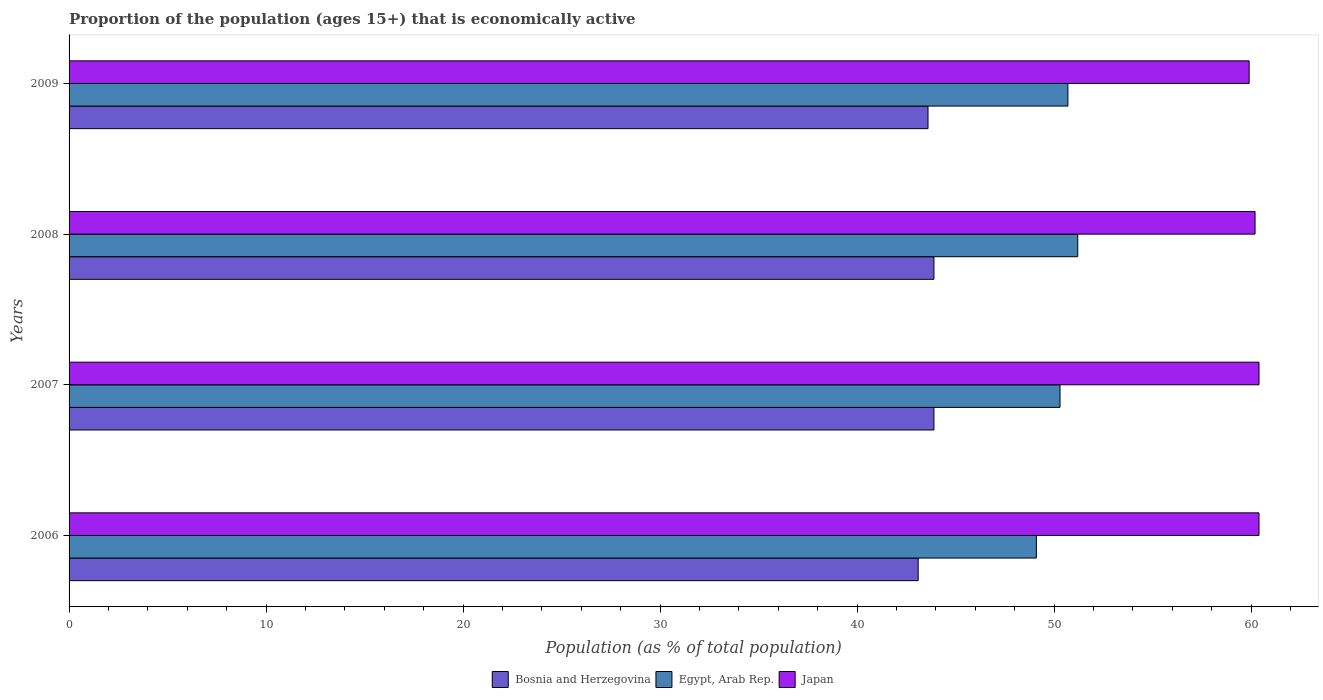Are the number of bars per tick equal to the number of legend labels?
Give a very brief answer. Yes. How many bars are there on the 3rd tick from the top?
Give a very brief answer. 3. What is the proportion of the population that is economically active in Bosnia and Herzegovina in 2008?
Your response must be concise. 43.9. Across all years, what is the maximum proportion of the population that is economically active in Japan?
Offer a very short reply. 60.4. Across all years, what is the minimum proportion of the population that is economically active in Japan?
Offer a terse response. 59.9. In which year was the proportion of the population that is economically active in Bosnia and Herzegovina maximum?
Provide a succinct answer. 2007. In which year was the proportion of the population that is economically active in Bosnia and Herzegovina minimum?
Provide a succinct answer. 2006. What is the total proportion of the population that is economically active in Bosnia and Herzegovina in the graph?
Make the answer very short. 174.5. What is the difference between the proportion of the population that is economically active in Japan in 2006 and that in 2009?
Make the answer very short. 0.5. What is the difference between the proportion of the population that is economically active in Japan in 2006 and the proportion of the population that is economically active in Egypt, Arab Rep. in 2009?
Offer a terse response. 9.7. What is the average proportion of the population that is economically active in Bosnia and Herzegovina per year?
Provide a succinct answer. 43.62. In the year 2006, what is the difference between the proportion of the population that is economically active in Japan and proportion of the population that is economically active in Bosnia and Herzegovina?
Provide a succinct answer. 17.3. In how many years, is the proportion of the population that is economically active in Egypt, Arab Rep. greater than 42 %?
Offer a terse response. 4. What is the ratio of the proportion of the population that is economically active in Egypt, Arab Rep. in 2006 to that in 2007?
Offer a very short reply. 0.98. Is the difference between the proportion of the population that is economically active in Japan in 2007 and 2009 greater than the difference between the proportion of the population that is economically active in Bosnia and Herzegovina in 2007 and 2009?
Make the answer very short. Yes. What is the difference between the highest and the second highest proportion of the population that is economically active in Bosnia and Herzegovina?
Your answer should be very brief. 0. What is the difference between the highest and the lowest proportion of the population that is economically active in Egypt, Arab Rep.?
Your response must be concise. 2.1. In how many years, is the proportion of the population that is economically active in Egypt, Arab Rep. greater than the average proportion of the population that is economically active in Egypt, Arab Rep. taken over all years?
Keep it short and to the point. 2. What does the 3rd bar from the top in 2009 represents?
Keep it short and to the point. Bosnia and Herzegovina. What does the 3rd bar from the bottom in 2006 represents?
Provide a succinct answer. Japan. Is it the case that in every year, the sum of the proportion of the population that is economically active in Egypt, Arab Rep. and proportion of the population that is economically active in Japan is greater than the proportion of the population that is economically active in Bosnia and Herzegovina?
Provide a short and direct response. Yes. How many bars are there?
Your answer should be compact. 12. What is the difference between two consecutive major ticks on the X-axis?
Make the answer very short. 10. Are the values on the major ticks of X-axis written in scientific E-notation?
Give a very brief answer. No. Does the graph contain any zero values?
Keep it short and to the point. No. What is the title of the graph?
Your answer should be compact. Proportion of the population (ages 15+) that is economically active. Does "Sint Maarten (Dutch part)" appear as one of the legend labels in the graph?
Offer a terse response. No. What is the label or title of the X-axis?
Offer a terse response. Population (as % of total population). What is the label or title of the Y-axis?
Your response must be concise. Years. What is the Population (as % of total population) of Bosnia and Herzegovina in 2006?
Ensure brevity in your answer.  43.1. What is the Population (as % of total population) in Egypt, Arab Rep. in 2006?
Keep it short and to the point. 49.1. What is the Population (as % of total population) in Japan in 2006?
Offer a very short reply. 60.4. What is the Population (as % of total population) of Bosnia and Herzegovina in 2007?
Your answer should be compact. 43.9. What is the Population (as % of total population) of Egypt, Arab Rep. in 2007?
Give a very brief answer. 50.3. What is the Population (as % of total population) in Japan in 2007?
Your response must be concise. 60.4. What is the Population (as % of total population) of Bosnia and Herzegovina in 2008?
Keep it short and to the point. 43.9. What is the Population (as % of total population) of Egypt, Arab Rep. in 2008?
Your response must be concise. 51.2. What is the Population (as % of total population) of Japan in 2008?
Give a very brief answer. 60.2. What is the Population (as % of total population) in Bosnia and Herzegovina in 2009?
Ensure brevity in your answer.  43.6. What is the Population (as % of total population) in Egypt, Arab Rep. in 2009?
Provide a short and direct response. 50.7. What is the Population (as % of total population) of Japan in 2009?
Offer a terse response. 59.9. Across all years, what is the maximum Population (as % of total population) in Bosnia and Herzegovina?
Provide a short and direct response. 43.9. Across all years, what is the maximum Population (as % of total population) in Egypt, Arab Rep.?
Make the answer very short. 51.2. Across all years, what is the maximum Population (as % of total population) in Japan?
Give a very brief answer. 60.4. Across all years, what is the minimum Population (as % of total population) in Bosnia and Herzegovina?
Ensure brevity in your answer.  43.1. Across all years, what is the minimum Population (as % of total population) in Egypt, Arab Rep.?
Offer a very short reply. 49.1. Across all years, what is the minimum Population (as % of total population) of Japan?
Provide a succinct answer. 59.9. What is the total Population (as % of total population) of Bosnia and Herzegovina in the graph?
Ensure brevity in your answer.  174.5. What is the total Population (as % of total population) in Egypt, Arab Rep. in the graph?
Make the answer very short. 201.3. What is the total Population (as % of total population) in Japan in the graph?
Keep it short and to the point. 240.9. What is the difference between the Population (as % of total population) of Japan in 2006 and that in 2007?
Give a very brief answer. 0. What is the difference between the Population (as % of total population) of Japan in 2006 and that in 2008?
Your answer should be compact. 0.2. What is the difference between the Population (as % of total population) in Bosnia and Herzegovina in 2007 and that in 2008?
Keep it short and to the point. 0. What is the difference between the Population (as % of total population) in Egypt, Arab Rep. in 2007 and that in 2008?
Provide a succinct answer. -0.9. What is the difference between the Population (as % of total population) in Japan in 2007 and that in 2008?
Your response must be concise. 0.2. What is the difference between the Population (as % of total population) of Bosnia and Herzegovina in 2007 and that in 2009?
Make the answer very short. 0.3. What is the difference between the Population (as % of total population) in Egypt, Arab Rep. in 2007 and that in 2009?
Give a very brief answer. -0.4. What is the difference between the Population (as % of total population) of Japan in 2007 and that in 2009?
Keep it short and to the point. 0.5. What is the difference between the Population (as % of total population) of Egypt, Arab Rep. in 2008 and that in 2009?
Ensure brevity in your answer.  0.5. What is the difference between the Population (as % of total population) in Japan in 2008 and that in 2009?
Make the answer very short. 0.3. What is the difference between the Population (as % of total population) of Bosnia and Herzegovina in 2006 and the Population (as % of total population) of Japan in 2007?
Give a very brief answer. -17.3. What is the difference between the Population (as % of total population) in Egypt, Arab Rep. in 2006 and the Population (as % of total population) in Japan in 2007?
Your answer should be very brief. -11.3. What is the difference between the Population (as % of total population) of Bosnia and Herzegovina in 2006 and the Population (as % of total population) of Egypt, Arab Rep. in 2008?
Provide a succinct answer. -8.1. What is the difference between the Population (as % of total population) in Bosnia and Herzegovina in 2006 and the Population (as % of total population) in Japan in 2008?
Your answer should be compact. -17.1. What is the difference between the Population (as % of total population) in Bosnia and Herzegovina in 2006 and the Population (as % of total population) in Japan in 2009?
Offer a very short reply. -16.8. What is the difference between the Population (as % of total population) in Bosnia and Herzegovina in 2007 and the Population (as % of total population) in Japan in 2008?
Your response must be concise. -16.3. What is the difference between the Population (as % of total population) of Bosnia and Herzegovina in 2008 and the Population (as % of total population) of Egypt, Arab Rep. in 2009?
Give a very brief answer. -6.8. What is the difference between the Population (as % of total population) of Bosnia and Herzegovina in 2008 and the Population (as % of total population) of Japan in 2009?
Give a very brief answer. -16. What is the difference between the Population (as % of total population) of Egypt, Arab Rep. in 2008 and the Population (as % of total population) of Japan in 2009?
Ensure brevity in your answer.  -8.7. What is the average Population (as % of total population) of Bosnia and Herzegovina per year?
Ensure brevity in your answer.  43.62. What is the average Population (as % of total population) in Egypt, Arab Rep. per year?
Offer a very short reply. 50.33. What is the average Population (as % of total population) of Japan per year?
Give a very brief answer. 60.23. In the year 2006, what is the difference between the Population (as % of total population) in Bosnia and Herzegovina and Population (as % of total population) in Japan?
Provide a short and direct response. -17.3. In the year 2007, what is the difference between the Population (as % of total population) of Bosnia and Herzegovina and Population (as % of total population) of Japan?
Your answer should be compact. -16.5. In the year 2007, what is the difference between the Population (as % of total population) in Egypt, Arab Rep. and Population (as % of total population) in Japan?
Your answer should be very brief. -10.1. In the year 2008, what is the difference between the Population (as % of total population) of Bosnia and Herzegovina and Population (as % of total population) of Egypt, Arab Rep.?
Give a very brief answer. -7.3. In the year 2008, what is the difference between the Population (as % of total population) of Bosnia and Herzegovina and Population (as % of total population) of Japan?
Provide a succinct answer. -16.3. In the year 2009, what is the difference between the Population (as % of total population) in Bosnia and Herzegovina and Population (as % of total population) in Egypt, Arab Rep.?
Provide a succinct answer. -7.1. In the year 2009, what is the difference between the Population (as % of total population) of Bosnia and Herzegovina and Population (as % of total population) of Japan?
Give a very brief answer. -16.3. What is the ratio of the Population (as % of total population) of Bosnia and Herzegovina in 2006 to that in 2007?
Provide a succinct answer. 0.98. What is the ratio of the Population (as % of total population) of Egypt, Arab Rep. in 2006 to that in 2007?
Your answer should be very brief. 0.98. What is the ratio of the Population (as % of total population) in Japan in 2006 to that in 2007?
Provide a short and direct response. 1. What is the ratio of the Population (as % of total population) of Bosnia and Herzegovina in 2006 to that in 2008?
Give a very brief answer. 0.98. What is the ratio of the Population (as % of total population) in Japan in 2006 to that in 2008?
Offer a terse response. 1. What is the ratio of the Population (as % of total population) of Egypt, Arab Rep. in 2006 to that in 2009?
Your answer should be compact. 0.97. What is the ratio of the Population (as % of total population) in Japan in 2006 to that in 2009?
Your answer should be very brief. 1.01. What is the ratio of the Population (as % of total population) of Egypt, Arab Rep. in 2007 to that in 2008?
Make the answer very short. 0.98. What is the ratio of the Population (as % of total population) of Japan in 2007 to that in 2009?
Your answer should be very brief. 1.01. What is the ratio of the Population (as % of total population) of Bosnia and Herzegovina in 2008 to that in 2009?
Your answer should be compact. 1.01. What is the ratio of the Population (as % of total population) of Egypt, Arab Rep. in 2008 to that in 2009?
Offer a terse response. 1.01. What is the difference between the highest and the second highest Population (as % of total population) of Bosnia and Herzegovina?
Provide a short and direct response. 0. What is the difference between the highest and the second highest Population (as % of total population) in Egypt, Arab Rep.?
Your response must be concise. 0.5. What is the difference between the highest and the second highest Population (as % of total population) in Japan?
Provide a short and direct response. 0. What is the difference between the highest and the lowest Population (as % of total population) of Bosnia and Herzegovina?
Ensure brevity in your answer.  0.8. What is the difference between the highest and the lowest Population (as % of total population) of Egypt, Arab Rep.?
Provide a short and direct response. 2.1. 